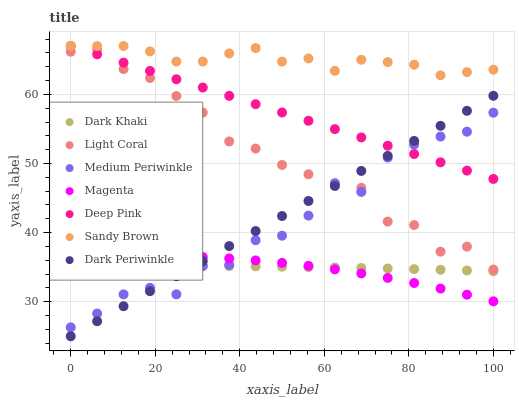Does Magenta have the minimum area under the curve?
Answer yes or no. Yes. Does Sandy Brown have the maximum area under the curve?
Answer yes or no. Yes. Does Deep Pink have the minimum area under the curve?
Answer yes or no. No. Does Deep Pink have the maximum area under the curve?
Answer yes or no. No. Is Dark Periwinkle the smoothest?
Answer yes or no. Yes. Is Medium Periwinkle the roughest?
Answer yes or no. Yes. Is Deep Pink the smoothest?
Answer yes or no. No. Is Deep Pink the roughest?
Answer yes or no. No. Does Dark Periwinkle have the lowest value?
Answer yes or no. Yes. Does Deep Pink have the lowest value?
Answer yes or no. No. Does Sandy Brown have the highest value?
Answer yes or no. Yes. Does Medium Periwinkle have the highest value?
Answer yes or no. No. Is Medium Periwinkle less than Sandy Brown?
Answer yes or no. Yes. Is Light Coral greater than Dark Khaki?
Answer yes or no. Yes. Does Dark Khaki intersect Magenta?
Answer yes or no. Yes. Is Dark Khaki less than Magenta?
Answer yes or no. No. Is Dark Khaki greater than Magenta?
Answer yes or no. No. Does Medium Periwinkle intersect Sandy Brown?
Answer yes or no. No. 